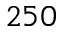Convert formula to latex. <formula><loc_0><loc_0><loc_500><loc_500>2 5 0</formula> 